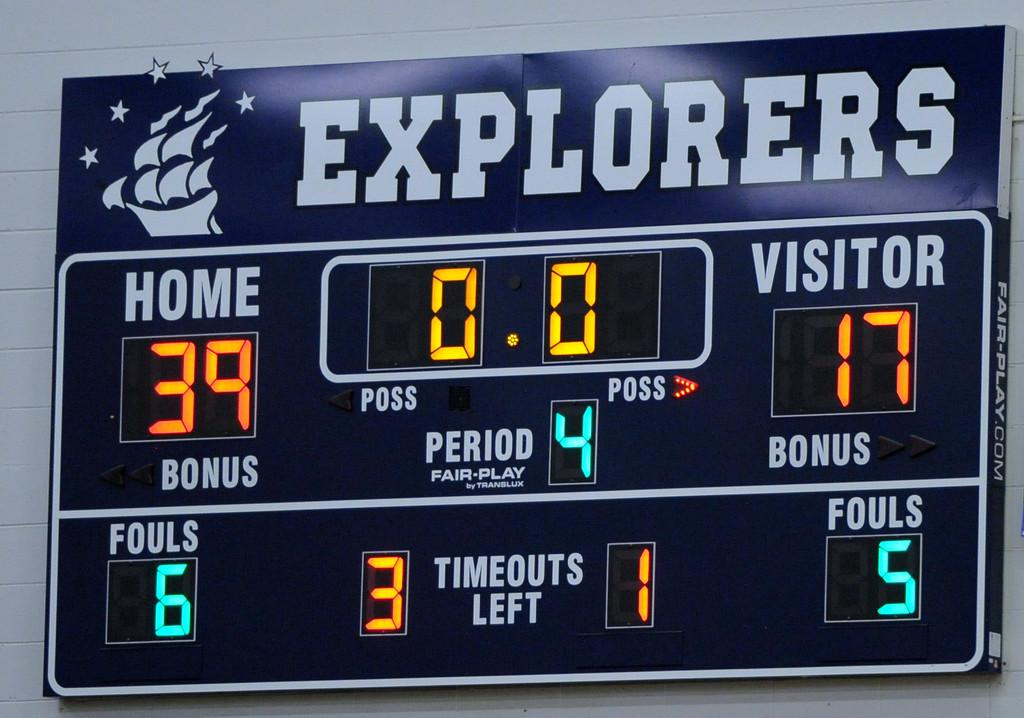<image>
Give a short and clear explanation of the subsequent image. Score board for the Explorers showing the score at 39-17. 